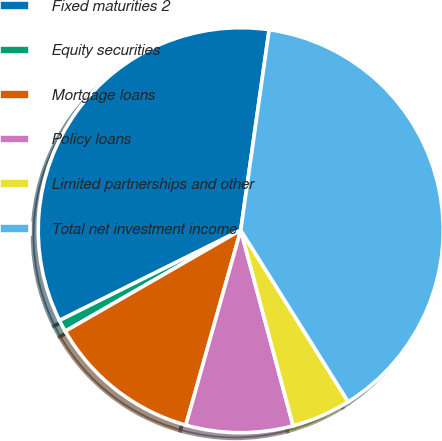Convert chart. <chart><loc_0><loc_0><loc_500><loc_500><pie_chart><fcel>Fixed maturities 2<fcel>Equity securities<fcel>Mortgage loans<fcel>Policy loans<fcel>Limited partnerships and other<fcel>Total net investment income<nl><fcel>34.59%<fcel>0.96%<fcel>12.32%<fcel>8.53%<fcel>4.74%<fcel>38.85%<nl></chart> 